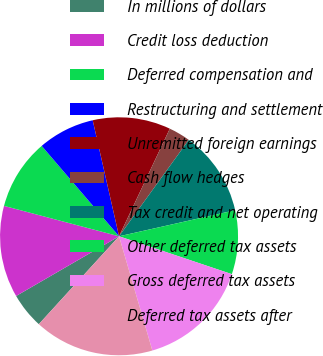<chart> <loc_0><loc_0><loc_500><loc_500><pie_chart><fcel>In millions of dollars<fcel>Credit loss deduction<fcel>Deferred compensation and<fcel>Restructuring and settlement<fcel>Unremitted foreign earnings<fcel>Cash flow hedges<fcel>Tax credit and net operating<fcel>Other deferred tax assets<fcel>Gross deferred tax assets<fcel>Deferred tax assets after<nl><fcel>4.86%<fcel>12.48%<fcel>9.62%<fcel>7.71%<fcel>10.57%<fcel>2.95%<fcel>11.52%<fcel>8.67%<fcel>15.33%<fcel>16.29%<nl></chart> 